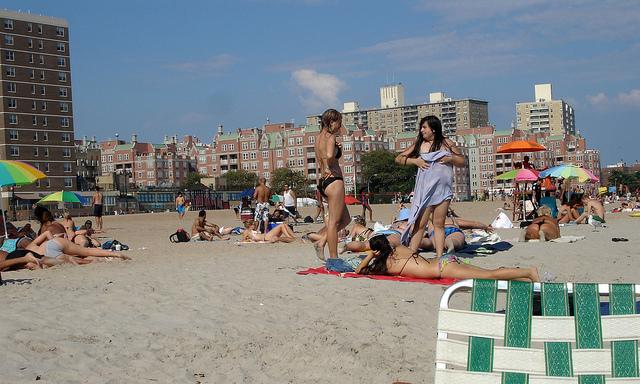The person under the orange umbrella is whom? lifeguard 